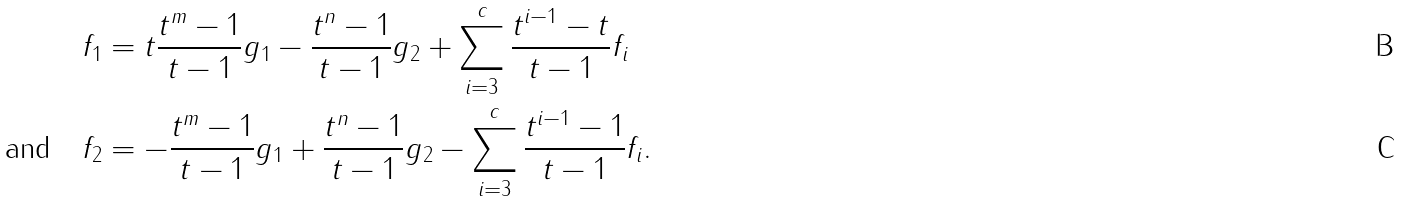Convert formula to latex. <formula><loc_0><loc_0><loc_500><loc_500>f _ { 1 } & = t \frac { t ^ { m } - 1 } { t - 1 } g _ { 1 } - \frac { t ^ { n } - 1 } { t - 1 } g _ { 2 } + \sum _ { i = 3 } ^ { c } \frac { t ^ { i - 1 } - t } { t - 1 } f _ { i } \\ \text {and} \quad f _ { 2 } & = - \frac { t ^ { m } - 1 } { t - 1 } g _ { 1 } + \frac { t ^ { n } - 1 } { t - 1 } g _ { 2 } - \sum _ { i = 3 } ^ { c } \frac { t ^ { i - 1 } - 1 } { t - 1 } f _ { i } .</formula> 